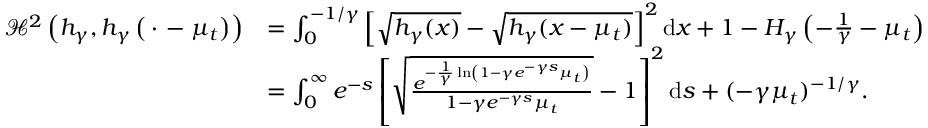Convert formula to latex. <formula><loc_0><loc_0><loc_500><loc_500>\begin{array} { r l } { { \ m a t h s c r { H } } ^ { 2 } \left ( h _ { \gamma } , h _ { \gamma } \left ( \, \cdot \, - \mu _ { t } \right ) \right ) } & { = \int _ { 0 } ^ { - 1 / \gamma } \left [ \sqrt { h _ { \gamma } ( x ) } - \sqrt { h _ { \gamma } ( x - \mu _ { t } ) } \right ] ^ { 2 } d x + 1 - H _ { \gamma } \left ( - \frac { 1 } { \gamma } - \mu _ { t } \right ) } \\ & { = \int _ { 0 } ^ { \infty } e ^ { - s } \left [ \sqrt { \frac { e ^ { - \frac { 1 } { \gamma } \ln \left ( 1 - \gamma e ^ { - \gamma s } \mu _ { t } \right ) } } { 1 - \gamma e ^ { - \gamma s } \mu _ { t } } } - 1 \right ] ^ { 2 } d s + ( - \gamma \mu _ { t } ) ^ { - 1 / \gamma } . } \end{array}</formula> 